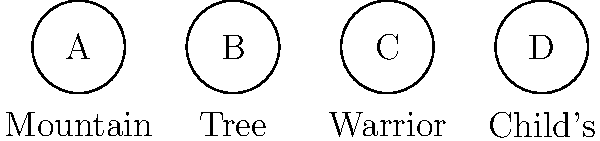Arrange the following yoga poses in the correct sequence for a mindfulness routine, starting with the most grounding pose and ending with the most relaxing:

A. Mountain Pose
B. Tree Pose
C. Warrior Pose
D. Child's Pose To create an effective mindfulness routine using these yoga poses, we should consider the following steps:

1. Start with the most grounding pose to establish a strong foundation and connection with the earth. Mountain Pose (A) is ideal for this, as it helps center the mind and body.

2. Progress to a balancing pose that builds on the groundwork of the previous pose. Tree Pose (B) is perfect, as it requires focus and stability while still maintaining a connection to the ground.

3. Move to a more active and challenging pose to engage the body and mind fully. Warrior Pose (C) fits this role, as it requires strength, focus, and proper alignment.

4. End with a restorative and relaxing pose to calm the mind and body. Child's Pose (D) is excellent for this, as it promotes relaxation and introspection.

This sequence allows for a gradual progression from grounding to challenging to relaxing, which is ideal for a mindfulness routine.
Answer: A, B, C, D 